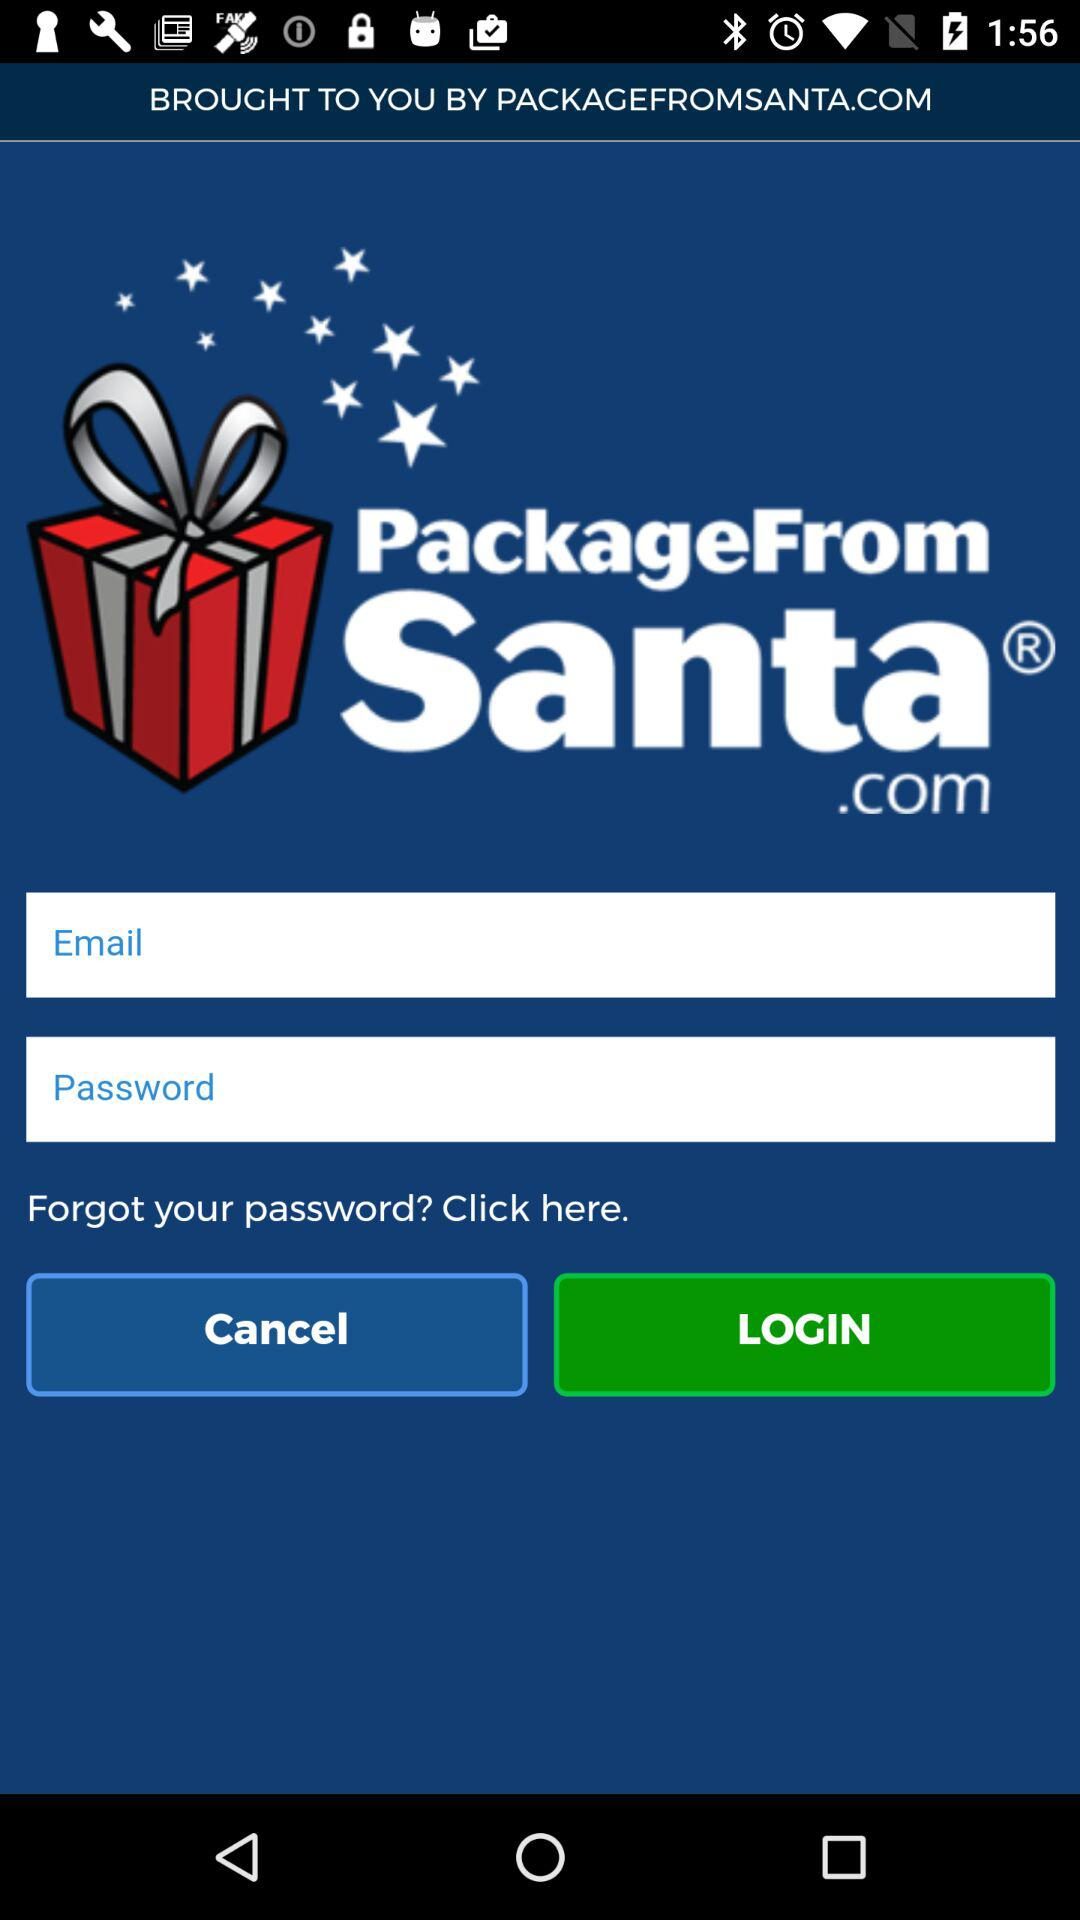How many text inputs are in the login form?
Answer the question using a single word or phrase. 2 